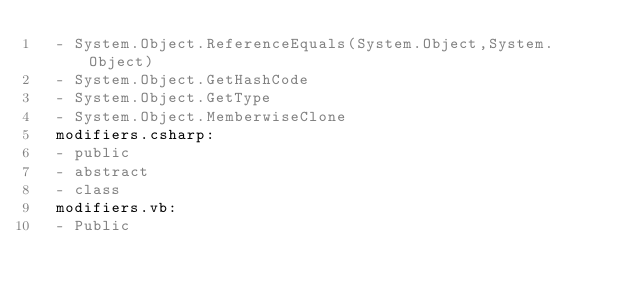Convert code to text. <code><loc_0><loc_0><loc_500><loc_500><_YAML_>  - System.Object.ReferenceEquals(System.Object,System.Object)
  - System.Object.GetHashCode
  - System.Object.GetType
  - System.Object.MemberwiseClone
  modifiers.csharp:
  - public
  - abstract
  - class
  modifiers.vb:
  - Public</code> 